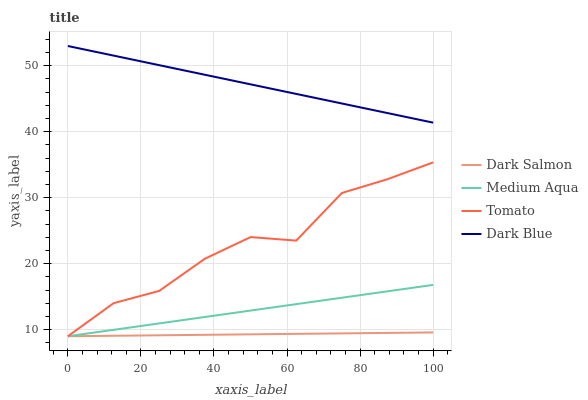Does Dark Salmon have the minimum area under the curve?
Answer yes or no. Yes. Does Dark Blue have the maximum area under the curve?
Answer yes or no. Yes. Does Medium Aqua have the minimum area under the curve?
Answer yes or no. No. Does Medium Aqua have the maximum area under the curve?
Answer yes or no. No. Is Dark Salmon the smoothest?
Answer yes or no. Yes. Is Tomato the roughest?
Answer yes or no. Yes. Is Dark Blue the smoothest?
Answer yes or no. No. Is Dark Blue the roughest?
Answer yes or no. No. Does Dark Blue have the lowest value?
Answer yes or no. No. Does Dark Blue have the highest value?
Answer yes or no. Yes. Does Medium Aqua have the highest value?
Answer yes or no. No. Is Dark Salmon less than Dark Blue?
Answer yes or no. Yes. Is Dark Blue greater than Tomato?
Answer yes or no. Yes. Does Medium Aqua intersect Dark Salmon?
Answer yes or no. Yes. Is Medium Aqua less than Dark Salmon?
Answer yes or no. No. Is Medium Aqua greater than Dark Salmon?
Answer yes or no. No. Does Dark Salmon intersect Dark Blue?
Answer yes or no. No. 